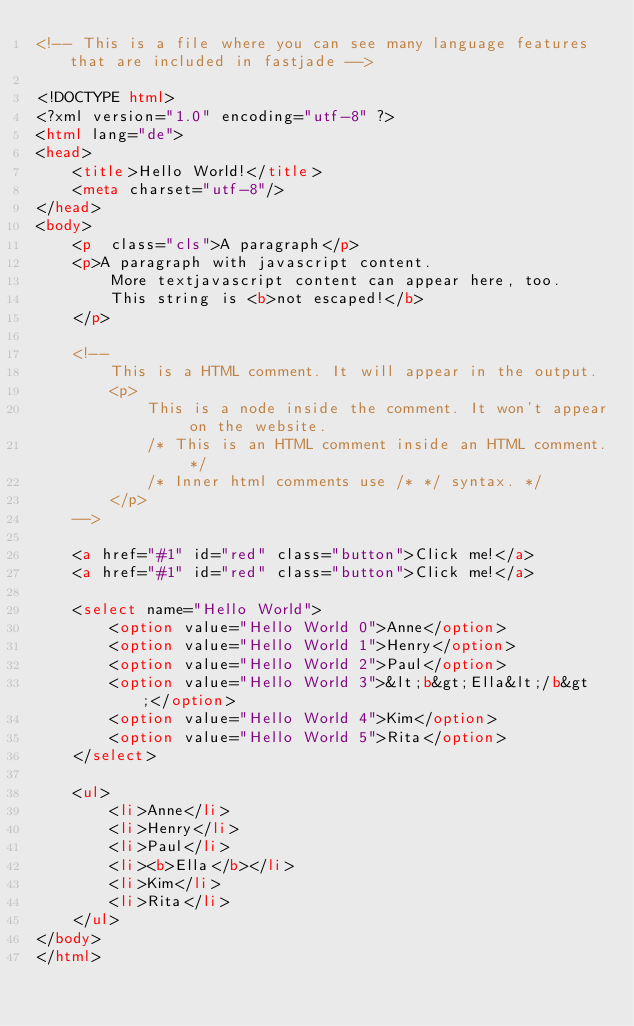<code> <loc_0><loc_0><loc_500><loc_500><_HTML_><!-- This is a file where you can see many language features that are included in fastjade -->

<!DOCTYPE html>
<?xml version="1.0" encoding="utf-8" ?>
<html lang="de">
<head>
    <title>Hello World!</title>
    <meta charset="utf-8"/>
</head>
<body>
    <p  class="cls">A paragraph</p>
    <p>A paragraph with javascript content.
        More textjavascript content can appear here, too.
        This string is <b>not escaped!</b>
    </p>

    <!--
        This is a HTML comment. It will appear in the output.
        <p>
            This is a node inside the comment. It won't appear on the website.
            /* This is an HTML comment inside an HTML comment. */
            /* Inner html comments use /* */ syntax. */
        </p>
    -->

    <a href="#1" id="red" class="button">Click me!</a>
    <a href="#1" id="red" class="button">Click me!</a>
    
    <select name="Hello World">
        <option value="Hello World 0">Anne</option>
        <option value="Hello World 1">Henry</option>
        <option value="Hello World 2">Paul</option>
        <option value="Hello World 3">&lt;b&gt;Ella&lt;/b&gt;</option>
        <option value="Hello World 4">Kim</option>
        <option value="Hello World 5">Rita</option>
    </select>
    
    <ul>
        <li>Anne</li>
        <li>Henry</li>
        <li>Paul</li>
        <li><b>Ella</b></li>
        <li>Kim</li>
        <li>Rita</li>
    </ul>
</body>
</html>
</code> 